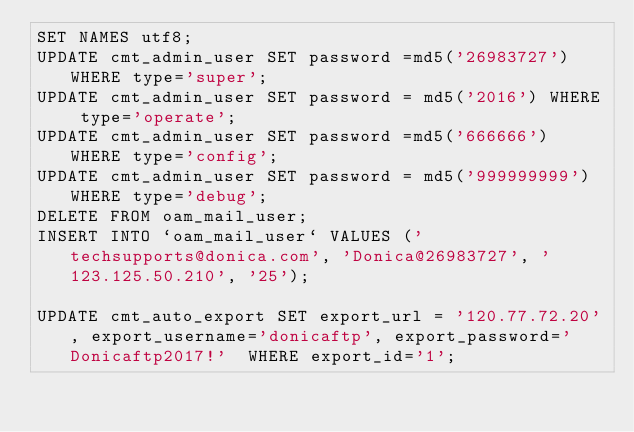Convert code to text. <code><loc_0><loc_0><loc_500><loc_500><_SQL_>SET NAMES utf8;
UPDATE cmt_admin_user SET password =md5('26983727')  WHERE type='super';
UPDATE cmt_admin_user SET password = md5('2016') WHERE type='operate';
UPDATE cmt_admin_user SET password =md5('666666')  WHERE type='config';
UPDATE cmt_admin_user SET password = md5('999999999') WHERE type='debug';
DELETE FROM oam_mail_user;
INSERT INTO `oam_mail_user` VALUES ('techsupports@donica.com', 'Donica@26983727', '123.125.50.210', '25');

UPDATE cmt_auto_export SET export_url = '120.77.72.20', export_username='donicaftp', export_password='Donicaftp2017!'  WHERE export_id='1';
</code> 